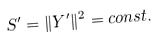<formula> <loc_0><loc_0><loc_500><loc_500>S ^ { \prime } = \| Y ^ { \prime } \| ^ { 2 } = c o n s t .</formula> 